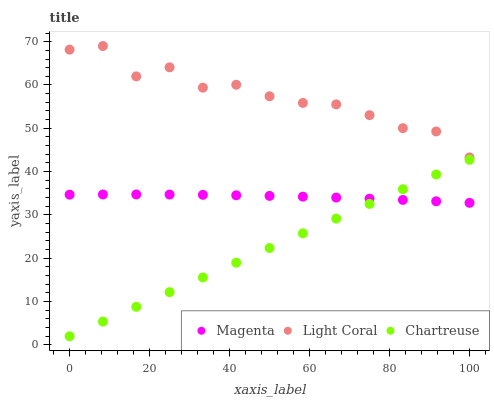Does Chartreuse have the minimum area under the curve?
Answer yes or no. Yes. Does Light Coral have the maximum area under the curve?
Answer yes or no. Yes. Does Magenta have the minimum area under the curve?
Answer yes or no. No. Does Magenta have the maximum area under the curve?
Answer yes or no. No. Is Chartreuse the smoothest?
Answer yes or no. Yes. Is Light Coral the roughest?
Answer yes or no. Yes. Is Magenta the smoothest?
Answer yes or no. No. Is Magenta the roughest?
Answer yes or no. No. Does Chartreuse have the lowest value?
Answer yes or no. Yes. Does Magenta have the lowest value?
Answer yes or no. No. Does Light Coral have the highest value?
Answer yes or no. Yes. Does Chartreuse have the highest value?
Answer yes or no. No. Is Magenta less than Light Coral?
Answer yes or no. Yes. Is Light Coral greater than Magenta?
Answer yes or no. Yes. Does Magenta intersect Chartreuse?
Answer yes or no. Yes. Is Magenta less than Chartreuse?
Answer yes or no. No. Is Magenta greater than Chartreuse?
Answer yes or no. No. Does Magenta intersect Light Coral?
Answer yes or no. No. 